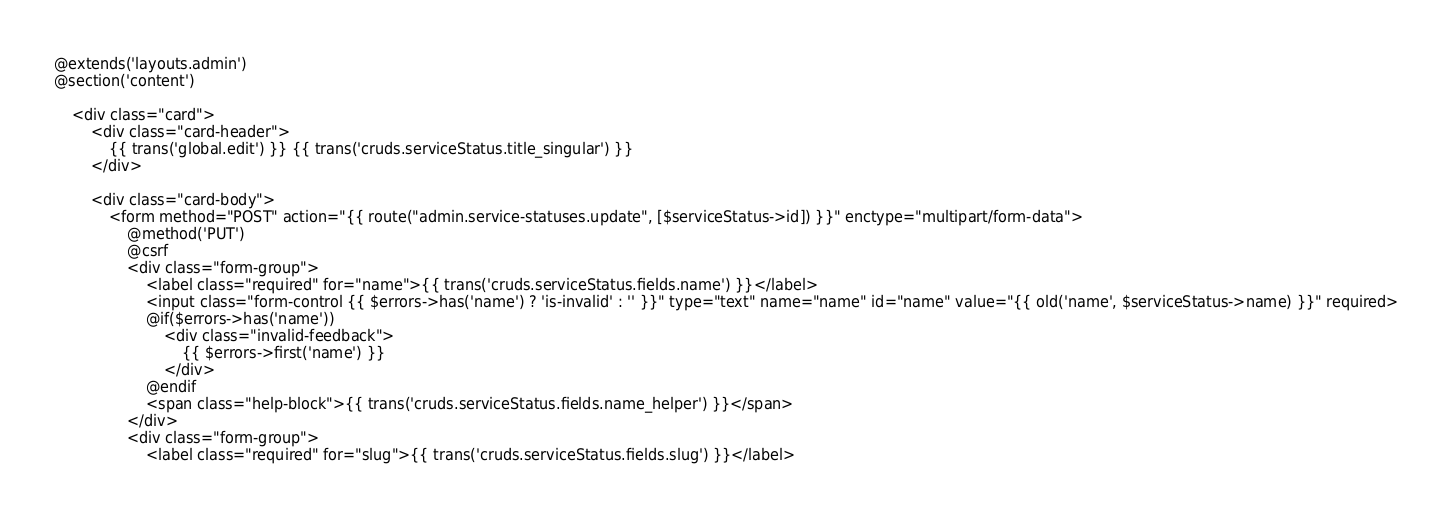<code> <loc_0><loc_0><loc_500><loc_500><_PHP_>@extends('layouts.admin')
@section('content')

    <div class="card">
        <div class="card-header">
            {{ trans('global.edit') }} {{ trans('cruds.serviceStatus.title_singular') }}
        </div>

        <div class="card-body">
            <form method="POST" action="{{ route("admin.service-statuses.update", [$serviceStatus->id]) }}" enctype="multipart/form-data">
                @method('PUT')
                @csrf
                <div class="form-group">
                    <label class="required" for="name">{{ trans('cruds.serviceStatus.fields.name') }}</label>
                    <input class="form-control {{ $errors->has('name') ? 'is-invalid' : '' }}" type="text" name="name" id="name" value="{{ old('name', $serviceStatus->name) }}" required>
                    @if($errors->has('name'))
                        <div class="invalid-feedback">
                            {{ $errors->first('name') }}
                        </div>
                    @endif
                    <span class="help-block">{{ trans('cruds.serviceStatus.fields.name_helper') }}</span>
                </div>
                <div class="form-group">
                    <label class="required" for="slug">{{ trans('cruds.serviceStatus.fields.slug') }}</label></code> 